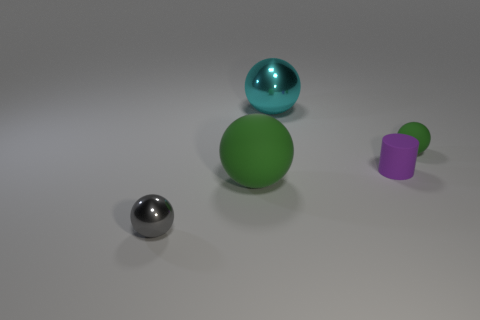Are there any matte cylinders that have the same color as the big metallic sphere?
Give a very brief answer. No. Is the shape of the green matte object on the right side of the big green sphere the same as  the gray thing?
Provide a succinct answer. Yes. What number of other cylinders are the same size as the purple cylinder?
Provide a succinct answer. 0. What number of purple cylinders are to the right of the metal ball on the right side of the small gray shiny ball?
Your answer should be compact. 1. Does the tiny ball in front of the big rubber ball have the same material as the big green thing?
Ensure brevity in your answer.  No. Does the green sphere that is on the right side of the large cyan thing have the same material as the green object that is to the left of the cyan object?
Your answer should be compact. Yes. Are there more rubber balls to the right of the large metallic object than tiny red objects?
Keep it short and to the point. Yes. The small ball that is to the right of the tiny matte object that is in front of the tiny green matte ball is what color?
Ensure brevity in your answer.  Green. What shape is the green matte thing that is the same size as the rubber cylinder?
Your answer should be very brief. Sphere. There is a object that is the same color as the small rubber sphere; what shape is it?
Your answer should be very brief. Sphere. 